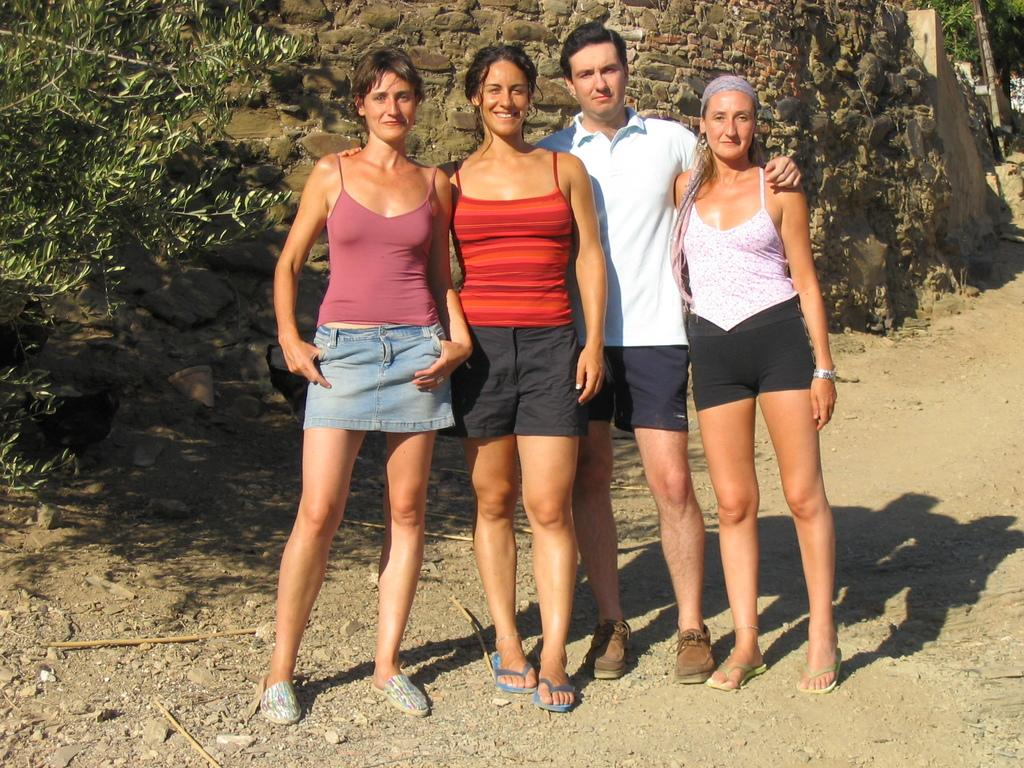How many people are in the image? There are three women and a man in the image, making a total of four people. What are the people in the image doing? The people are standing on the ground. What can be seen in the background of the image? There is a wall and trees in the background of the image. Is there a whip visible in the image? No, there is no whip present in the image. Can you see a hill in the background of the image? No, there is no hill visible in the image; only a wall and trees are present in the background. 